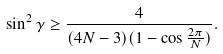Convert formula to latex. <formula><loc_0><loc_0><loc_500><loc_500>\sin ^ { 2 } \gamma \geq \frac { 4 } { ( 4 N - 3 ) ( 1 - \cos \frac { 2 \pi } { N } ) } .</formula> 